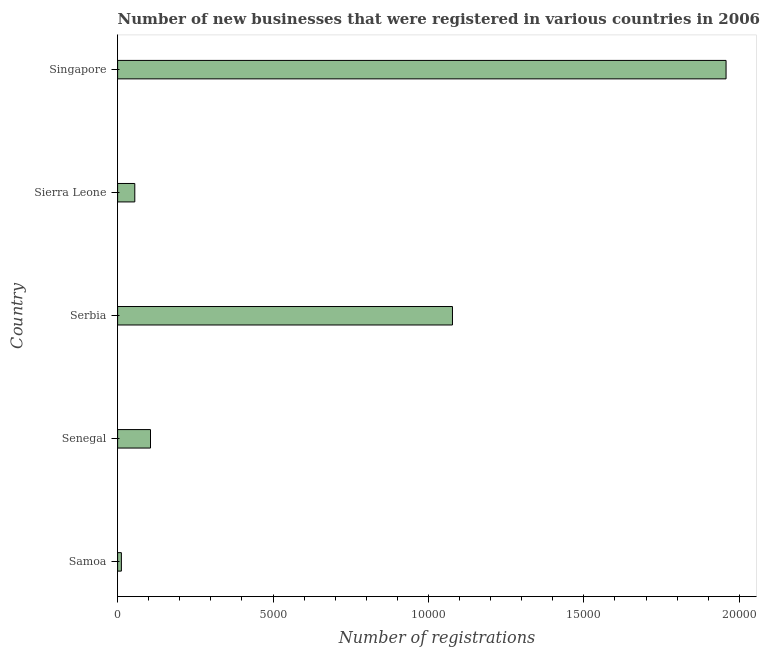Does the graph contain any zero values?
Your response must be concise. No. Does the graph contain grids?
Provide a short and direct response. No. What is the title of the graph?
Provide a succinct answer. Number of new businesses that were registered in various countries in 2006. What is the label or title of the X-axis?
Provide a short and direct response. Number of registrations. What is the number of new business registrations in Senegal?
Ensure brevity in your answer.  1058. Across all countries, what is the maximum number of new business registrations?
Give a very brief answer. 1.96e+04. Across all countries, what is the minimum number of new business registrations?
Your answer should be compact. 121. In which country was the number of new business registrations maximum?
Your answer should be very brief. Singapore. In which country was the number of new business registrations minimum?
Offer a terse response. Samoa. What is the sum of the number of new business registrations?
Your response must be concise. 3.21e+04. What is the difference between the number of new business registrations in Samoa and Sierra Leone?
Ensure brevity in your answer.  -432. What is the average number of new business registrations per country?
Provide a succinct answer. 6416. What is the median number of new business registrations?
Give a very brief answer. 1058. In how many countries, is the number of new business registrations greater than 13000 ?
Your response must be concise. 1. What is the ratio of the number of new business registrations in Serbia to that in Singapore?
Your answer should be compact. 0.55. Is the number of new business registrations in Serbia less than that in Singapore?
Your answer should be compact. Yes. What is the difference between the highest and the second highest number of new business registrations?
Your answer should be very brief. 8802. Is the sum of the number of new business registrations in Senegal and Serbia greater than the maximum number of new business registrations across all countries?
Offer a terse response. No. What is the difference between the highest and the lowest number of new business registrations?
Offer a very short reply. 1.95e+04. How many bars are there?
Offer a very short reply. 5. What is the Number of registrations of Samoa?
Make the answer very short. 121. What is the Number of registrations of Senegal?
Offer a very short reply. 1058. What is the Number of registrations of Serbia?
Your answer should be compact. 1.08e+04. What is the Number of registrations in Sierra Leone?
Keep it short and to the point. 553. What is the Number of registrations of Singapore?
Your answer should be very brief. 1.96e+04. What is the difference between the Number of registrations in Samoa and Senegal?
Ensure brevity in your answer.  -937. What is the difference between the Number of registrations in Samoa and Serbia?
Provide a short and direct response. -1.07e+04. What is the difference between the Number of registrations in Samoa and Sierra Leone?
Offer a very short reply. -432. What is the difference between the Number of registrations in Samoa and Singapore?
Offer a terse response. -1.95e+04. What is the difference between the Number of registrations in Senegal and Serbia?
Provide a short and direct response. -9715. What is the difference between the Number of registrations in Senegal and Sierra Leone?
Your answer should be compact. 505. What is the difference between the Number of registrations in Senegal and Singapore?
Provide a short and direct response. -1.85e+04. What is the difference between the Number of registrations in Serbia and Sierra Leone?
Give a very brief answer. 1.02e+04. What is the difference between the Number of registrations in Serbia and Singapore?
Ensure brevity in your answer.  -8802. What is the difference between the Number of registrations in Sierra Leone and Singapore?
Make the answer very short. -1.90e+04. What is the ratio of the Number of registrations in Samoa to that in Senegal?
Provide a short and direct response. 0.11. What is the ratio of the Number of registrations in Samoa to that in Serbia?
Provide a succinct answer. 0.01. What is the ratio of the Number of registrations in Samoa to that in Sierra Leone?
Your response must be concise. 0.22. What is the ratio of the Number of registrations in Samoa to that in Singapore?
Give a very brief answer. 0.01. What is the ratio of the Number of registrations in Senegal to that in Serbia?
Your response must be concise. 0.1. What is the ratio of the Number of registrations in Senegal to that in Sierra Leone?
Your answer should be compact. 1.91. What is the ratio of the Number of registrations in Senegal to that in Singapore?
Keep it short and to the point. 0.05. What is the ratio of the Number of registrations in Serbia to that in Sierra Leone?
Your response must be concise. 19.48. What is the ratio of the Number of registrations in Serbia to that in Singapore?
Your response must be concise. 0.55. What is the ratio of the Number of registrations in Sierra Leone to that in Singapore?
Your response must be concise. 0.03. 